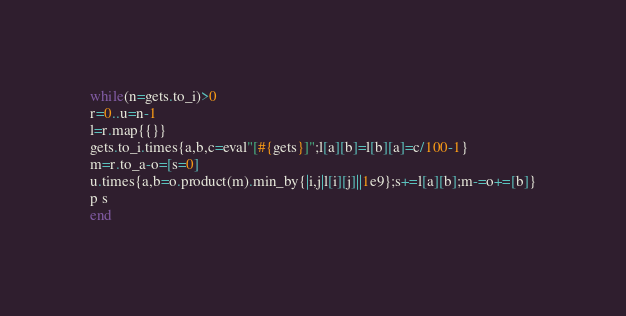Convert code to text. <code><loc_0><loc_0><loc_500><loc_500><_Ruby_>while(n=gets.to_i)>0
r=0..u=n-1
l=r.map{{}}
gets.to_i.times{a,b,c=eval"[#{gets}]";l[a][b]=l[b][a]=c/100-1}
m=r.to_a-o=[s=0]
u.times{a,b=o.product(m).min_by{|i,j|l[i][j]||1e9};s+=l[a][b];m-=o+=[b]}
p s
end</code> 